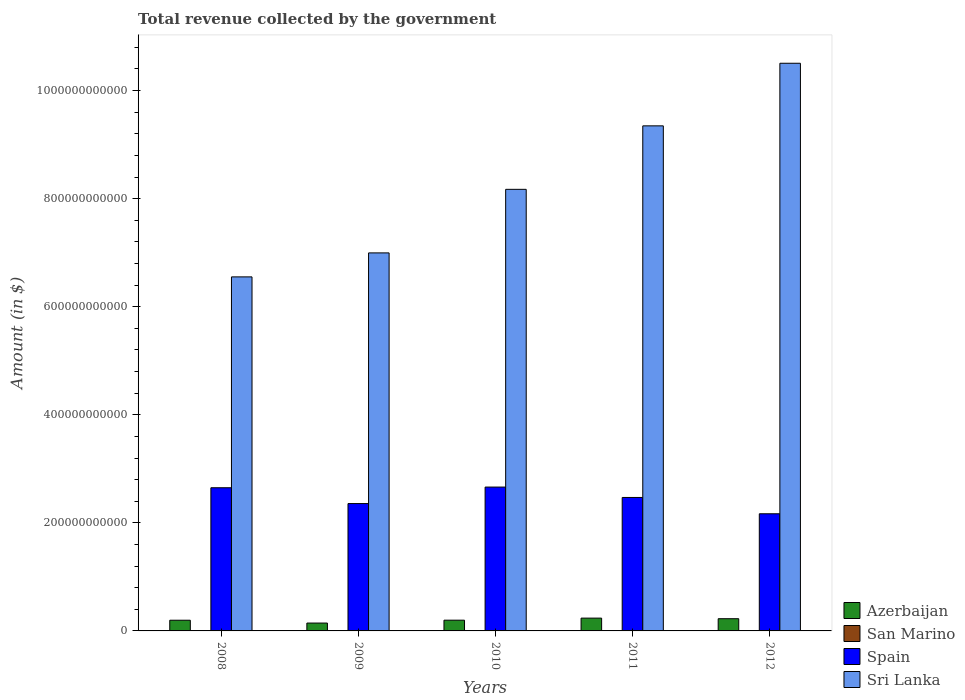How many different coloured bars are there?
Give a very brief answer. 4. Are the number of bars per tick equal to the number of legend labels?
Give a very brief answer. Yes. Are the number of bars on each tick of the X-axis equal?
Provide a short and direct response. Yes. What is the total revenue collected by the government in Azerbaijan in 2009?
Offer a terse response. 1.46e+1. Across all years, what is the maximum total revenue collected by the government in Azerbaijan?
Offer a very short reply. 2.37e+1. Across all years, what is the minimum total revenue collected by the government in Sri Lanka?
Keep it short and to the point. 6.55e+11. What is the total total revenue collected by the government in Sri Lanka in the graph?
Give a very brief answer. 4.16e+12. What is the difference between the total revenue collected by the government in Spain in 2011 and that in 2012?
Offer a terse response. 3.02e+1. What is the difference between the total revenue collected by the government in Sri Lanka in 2010 and the total revenue collected by the government in Azerbaijan in 2009?
Your answer should be very brief. 8.03e+11. What is the average total revenue collected by the government in Azerbaijan per year?
Keep it short and to the point. 2.01e+1. In the year 2010, what is the difference between the total revenue collected by the government in Spain and total revenue collected by the government in Azerbaijan?
Ensure brevity in your answer.  2.46e+11. In how many years, is the total revenue collected by the government in Azerbaijan greater than 80000000000 $?
Your response must be concise. 0. What is the ratio of the total revenue collected by the government in Azerbaijan in 2011 to that in 2012?
Your answer should be very brief. 1.05. Is the total revenue collected by the government in Sri Lanka in 2008 less than that in 2009?
Give a very brief answer. Yes. Is the difference between the total revenue collected by the government in Spain in 2010 and 2011 greater than the difference between the total revenue collected by the government in Azerbaijan in 2010 and 2011?
Your response must be concise. Yes. What is the difference between the highest and the second highest total revenue collected by the government in Azerbaijan?
Give a very brief answer. 1.09e+09. What is the difference between the highest and the lowest total revenue collected by the government in Sri Lanka?
Your response must be concise. 3.95e+11. Is it the case that in every year, the sum of the total revenue collected by the government in Spain and total revenue collected by the government in Azerbaijan is greater than the sum of total revenue collected by the government in Sri Lanka and total revenue collected by the government in San Marino?
Offer a very short reply. Yes. What does the 1st bar from the left in 2010 represents?
Offer a very short reply. Azerbaijan. What does the 4th bar from the right in 2009 represents?
Give a very brief answer. Azerbaijan. What is the difference between two consecutive major ticks on the Y-axis?
Offer a terse response. 2.00e+11. Does the graph contain any zero values?
Ensure brevity in your answer.  No. Does the graph contain grids?
Ensure brevity in your answer.  No. Where does the legend appear in the graph?
Give a very brief answer. Bottom right. How many legend labels are there?
Provide a short and direct response. 4. What is the title of the graph?
Provide a succinct answer. Total revenue collected by the government. What is the label or title of the X-axis?
Offer a terse response. Years. What is the label or title of the Y-axis?
Provide a succinct answer. Amount (in $). What is the Amount (in $) in Azerbaijan in 2008?
Your answer should be very brief. 1.98e+1. What is the Amount (in $) of San Marino in 2008?
Ensure brevity in your answer.  5.91e+08. What is the Amount (in $) of Spain in 2008?
Provide a short and direct response. 2.65e+11. What is the Amount (in $) of Sri Lanka in 2008?
Ensure brevity in your answer.  6.55e+11. What is the Amount (in $) of Azerbaijan in 2009?
Offer a terse response. 1.46e+1. What is the Amount (in $) of San Marino in 2009?
Offer a very short reply. 5.62e+08. What is the Amount (in $) in Spain in 2009?
Your answer should be very brief. 2.36e+11. What is the Amount (in $) of Sri Lanka in 2009?
Make the answer very short. 7.00e+11. What is the Amount (in $) of Azerbaijan in 2010?
Your answer should be very brief. 1.99e+1. What is the Amount (in $) in San Marino in 2010?
Your answer should be very brief. 5.31e+08. What is the Amount (in $) in Spain in 2010?
Keep it short and to the point. 2.66e+11. What is the Amount (in $) in Sri Lanka in 2010?
Give a very brief answer. 8.17e+11. What is the Amount (in $) in Azerbaijan in 2011?
Keep it short and to the point. 2.37e+1. What is the Amount (in $) of San Marino in 2011?
Ensure brevity in your answer.  5.23e+08. What is the Amount (in $) in Spain in 2011?
Give a very brief answer. 2.47e+11. What is the Amount (in $) in Sri Lanka in 2011?
Keep it short and to the point. 9.35e+11. What is the Amount (in $) of Azerbaijan in 2012?
Your answer should be very brief. 2.26e+1. What is the Amount (in $) of San Marino in 2012?
Give a very brief answer. 5.53e+08. What is the Amount (in $) of Spain in 2012?
Make the answer very short. 2.17e+11. What is the Amount (in $) in Sri Lanka in 2012?
Keep it short and to the point. 1.05e+12. Across all years, what is the maximum Amount (in $) of Azerbaijan?
Your answer should be compact. 2.37e+1. Across all years, what is the maximum Amount (in $) of San Marino?
Offer a terse response. 5.91e+08. Across all years, what is the maximum Amount (in $) in Spain?
Your answer should be very brief. 2.66e+11. Across all years, what is the maximum Amount (in $) of Sri Lanka?
Provide a succinct answer. 1.05e+12. Across all years, what is the minimum Amount (in $) in Azerbaijan?
Your response must be concise. 1.46e+1. Across all years, what is the minimum Amount (in $) of San Marino?
Your answer should be compact. 5.23e+08. Across all years, what is the minimum Amount (in $) in Spain?
Keep it short and to the point. 2.17e+11. Across all years, what is the minimum Amount (in $) in Sri Lanka?
Offer a very short reply. 6.55e+11. What is the total Amount (in $) in Azerbaijan in the graph?
Ensure brevity in your answer.  1.01e+11. What is the total Amount (in $) in San Marino in the graph?
Keep it short and to the point. 2.76e+09. What is the total Amount (in $) in Spain in the graph?
Provide a short and direct response. 1.23e+12. What is the total Amount (in $) in Sri Lanka in the graph?
Provide a succinct answer. 4.16e+12. What is the difference between the Amount (in $) in Azerbaijan in 2008 and that in 2009?
Your answer should be compact. 5.23e+09. What is the difference between the Amount (in $) in San Marino in 2008 and that in 2009?
Your response must be concise. 2.87e+07. What is the difference between the Amount (in $) of Spain in 2008 and that in 2009?
Keep it short and to the point. 2.93e+1. What is the difference between the Amount (in $) in Sri Lanka in 2008 and that in 2009?
Keep it short and to the point. -4.44e+1. What is the difference between the Amount (in $) in Azerbaijan in 2008 and that in 2010?
Provide a short and direct response. -9.75e+07. What is the difference between the Amount (in $) of San Marino in 2008 and that in 2010?
Provide a short and direct response. 6.02e+07. What is the difference between the Amount (in $) of Spain in 2008 and that in 2010?
Keep it short and to the point. -1.23e+09. What is the difference between the Amount (in $) of Sri Lanka in 2008 and that in 2010?
Ensure brevity in your answer.  -1.62e+11. What is the difference between the Amount (in $) in Azerbaijan in 2008 and that in 2011?
Your answer should be very brief. -3.90e+09. What is the difference between the Amount (in $) of San Marino in 2008 and that in 2011?
Ensure brevity in your answer.  6.76e+07. What is the difference between the Amount (in $) of Spain in 2008 and that in 2011?
Your answer should be compact. 1.80e+1. What is the difference between the Amount (in $) of Sri Lanka in 2008 and that in 2011?
Make the answer very short. -2.80e+11. What is the difference between the Amount (in $) in Azerbaijan in 2008 and that in 2012?
Your response must be concise. -2.81e+09. What is the difference between the Amount (in $) of San Marino in 2008 and that in 2012?
Keep it short and to the point. 3.76e+07. What is the difference between the Amount (in $) in Spain in 2008 and that in 2012?
Provide a short and direct response. 4.82e+1. What is the difference between the Amount (in $) in Sri Lanka in 2008 and that in 2012?
Give a very brief answer. -3.95e+11. What is the difference between the Amount (in $) in Azerbaijan in 2009 and that in 2010?
Your answer should be very brief. -5.33e+09. What is the difference between the Amount (in $) in San Marino in 2009 and that in 2010?
Provide a succinct answer. 3.15e+07. What is the difference between the Amount (in $) in Spain in 2009 and that in 2010?
Make the answer very short. -3.05e+1. What is the difference between the Amount (in $) of Sri Lanka in 2009 and that in 2010?
Make the answer very short. -1.18e+11. What is the difference between the Amount (in $) of Azerbaijan in 2009 and that in 2011?
Your response must be concise. -9.13e+09. What is the difference between the Amount (in $) of San Marino in 2009 and that in 2011?
Ensure brevity in your answer.  3.89e+07. What is the difference between the Amount (in $) of Spain in 2009 and that in 2011?
Offer a very short reply. -1.13e+1. What is the difference between the Amount (in $) in Sri Lanka in 2009 and that in 2011?
Offer a terse response. -2.35e+11. What is the difference between the Amount (in $) in Azerbaijan in 2009 and that in 2012?
Your answer should be compact. -8.04e+09. What is the difference between the Amount (in $) in San Marino in 2009 and that in 2012?
Provide a succinct answer. 8.90e+06. What is the difference between the Amount (in $) in Spain in 2009 and that in 2012?
Offer a very short reply. 1.89e+1. What is the difference between the Amount (in $) of Sri Lanka in 2009 and that in 2012?
Provide a succinct answer. -3.51e+11. What is the difference between the Amount (in $) of Azerbaijan in 2010 and that in 2011?
Provide a short and direct response. -3.80e+09. What is the difference between the Amount (in $) in San Marino in 2010 and that in 2011?
Give a very brief answer. 7.36e+06. What is the difference between the Amount (in $) of Spain in 2010 and that in 2011?
Keep it short and to the point. 1.92e+1. What is the difference between the Amount (in $) in Sri Lanka in 2010 and that in 2011?
Your answer should be compact. -1.17e+11. What is the difference between the Amount (in $) in Azerbaijan in 2010 and that in 2012?
Your answer should be compact. -2.71e+09. What is the difference between the Amount (in $) in San Marino in 2010 and that in 2012?
Keep it short and to the point. -2.26e+07. What is the difference between the Amount (in $) in Spain in 2010 and that in 2012?
Your answer should be compact. 4.94e+1. What is the difference between the Amount (in $) of Sri Lanka in 2010 and that in 2012?
Ensure brevity in your answer.  -2.33e+11. What is the difference between the Amount (in $) of Azerbaijan in 2011 and that in 2012?
Offer a very short reply. 1.09e+09. What is the difference between the Amount (in $) of San Marino in 2011 and that in 2012?
Keep it short and to the point. -3.00e+07. What is the difference between the Amount (in $) of Spain in 2011 and that in 2012?
Keep it short and to the point. 3.02e+1. What is the difference between the Amount (in $) in Sri Lanka in 2011 and that in 2012?
Provide a succinct answer. -1.16e+11. What is the difference between the Amount (in $) of Azerbaijan in 2008 and the Amount (in $) of San Marino in 2009?
Make the answer very short. 1.92e+1. What is the difference between the Amount (in $) in Azerbaijan in 2008 and the Amount (in $) in Spain in 2009?
Your answer should be compact. -2.16e+11. What is the difference between the Amount (in $) of Azerbaijan in 2008 and the Amount (in $) of Sri Lanka in 2009?
Offer a terse response. -6.80e+11. What is the difference between the Amount (in $) of San Marino in 2008 and the Amount (in $) of Spain in 2009?
Make the answer very short. -2.35e+11. What is the difference between the Amount (in $) of San Marino in 2008 and the Amount (in $) of Sri Lanka in 2009?
Ensure brevity in your answer.  -6.99e+11. What is the difference between the Amount (in $) of Spain in 2008 and the Amount (in $) of Sri Lanka in 2009?
Offer a very short reply. -4.35e+11. What is the difference between the Amount (in $) of Azerbaijan in 2008 and the Amount (in $) of San Marino in 2010?
Offer a very short reply. 1.93e+1. What is the difference between the Amount (in $) in Azerbaijan in 2008 and the Amount (in $) in Spain in 2010?
Your answer should be very brief. -2.46e+11. What is the difference between the Amount (in $) in Azerbaijan in 2008 and the Amount (in $) in Sri Lanka in 2010?
Your response must be concise. -7.97e+11. What is the difference between the Amount (in $) of San Marino in 2008 and the Amount (in $) of Spain in 2010?
Keep it short and to the point. -2.66e+11. What is the difference between the Amount (in $) of San Marino in 2008 and the Amount (in $) of Sri Lanka in 2010?
Offer a terse response. -8.17e+11. What is the difference between the Amount (in $) of Spain in 2008 and the Amount (in $) of Sri Lanka in 2010?
Give a very brief answer. -5.52e+11. What is the difference between the Amount (in $) in Azerbaijan in 2008 and the Amount (in $) in San Marino in 2011?
Keep it short and to the point. 1.93e+1. What is the difference between the Amount (in $) in Azerbaijan in 2008 and the Amount (in $) in Spain in 2011?
Offer a terse response. -2.27e+11. What is the difference between the Amount (in $) of Azerbaijan in 2008 and the Amount (in $) of Sri Lanka in 2011?
Provide a short and direct response. -9.15e+11. What is the difference between the Amount (in $) in San Marino in 2008 and the Amount (in $) in Spain in 2011?
Keep it short and to the point. -2.46e+11. What is the difference between the Amount (in $) in San Marino in 2008 and the Amount (in $) in Sri Lanka in 2011?
Your answer should be compact. -9.34e+11. What is the difference between the Amount (in $) of Spain in 2008 and the Amount (in $) of Sri Lanka in 2011?
Your response must be concise. -6.70e+11. What is the difference between the Amount (in $) in Azerbaijan in 2008 and the Amount (in $) in San Marino in 2012?
Offer a very short reply. 1.92e+1. What is the difference between the Amount (in $) of Azerbaijan in 2008 and the Amount (in $) of Spain in 2012?
Provide a short and direct response. -1.97e+11. What is the difference between the Amount (in $) of Azerbaijan in 2008 and the Amount (in $) of Sri Lanka in 2012?
Your response must be concise. -1.03e+12. What is the difference between the Amount (in $) in San Marino in 2008 and the Amount (in $) in Spain in 2012?
Give a very brief answer. -2.16e+11. What is the difference between the Amount (in $) of San Marino in 2008 and the Amount (in $) of Sri Lanka in 2012?
Provide a succinct answer. -1.05e+12. What is the difference between the Amount (in $) of Spain in 2008 and the Amount (in $) of Sri Lanka in 2012?
Your answer should be very brief. -7.86e+11. What is the difference between the Amount (in $) of Azerbaijan in 2009 and the Amount (in $) of San Marino in 2010?
Keep it short and to the point. 1.40e+1. What is the difference between the Amount (in $) in Azerbaijan in 2009 and the Amount (in $) in Spain in 2010?
Give a very brief answer. -2.52e+11. What is the difference between the Amount (in $) in Azerbaijan in 2009 and the Amount (in $) in Sri Lanka in 2010?
Offer a very short reply. -8.03e+11. What is the difference between the Amount (in $) of San Marino in 2009 and the Amount (in $) of Spain in 2010?
Offer a very short reply. -2.66e+11. What is the difference between the Amount (in $) of San Marino in 2009 and the Amount (in $) of Sri Lanka in 2010?
Make the answer very short. -8.17e+11. What is the difference between the Amount (in $) in Spain in 2009 and the Amount (in $) in Sri Lanka in 2010?
Offer a terse response. -5.82e+11. What is the difference between the Amount (in $) of Azerbaijan in 2009 and the Amount (in $) of San Marino in 2011?
Offer a terse response. 1.40e+1. What is the difference between the Amount (in $) in Azerbaijan in 2009 and the Amount (in $) in Spain in 2011?
Make the answer very short. -2.32e+11. What is the difference between the Amount (in $) of Azerbaijan in 2009 and the Amount (in $) of Sri Lanka in 2011?
Your answer should be compact. -9.20e+11. What is the difference between the Amount (in $) in San Marino in 2009 and the Amount (in $) in Spain in 2011?
Your answer should be very brief. -2.46e+11. What is the difference between the Amount (in $) of San Marino in 2009 and the Amount (in $) of Sri Lanka in 2011?
Your response must be concise. -9.34e+11. What is the difference between the Amount (in $) of Spain in 2009 and the Amount (in $) of Sri Lanka in 2011?
Provide a succinct answer. -6.99e+11. What is the difference between the Amount (in $) of Azerbaijan in 2009 and the Amount (in $) of San Marino in 2012?
Offer a terse response. 1.40e+1. What is the difference between the Amount (in $) in Azerbaijan in 2009 and the Amount (in $) in Spain in 2012?
Give a very brief answer. -2.02e+11. What is the difference between the Amount (in $) in Azerbaijan in 2009 and the Amount (in $) in Sri Lanka in 2012?
Offer a very short reply. -1.04e+12. What is the difference between the Amount (in $) of San Marino in 2009 and the Amount (in $) of Spain in 2012?
Make the answer very short. -2.16e+11. What is the difference between the Amount (in $) in San Marino in 2009 and the Amount (in $) in Sri Lanka in 2012?
Offer a terse response. -1.05e+12. What is the difference between the Amount (in $) of Spain in 2009 and the Amount (in $) of Sri Lanka in 2012?
Your answer should be very brief. -8.15e+11. What is the difference between the Amount (in $) in Azerbaijan in 2010 and the Amount (in $) in San Marino in 2011?
Keep it short and to the point. 1.94e+1. What is the difference between the Amount (in $) in Azerbaijan in 2010 and the Amount (in $) in Spain in 2011?
Offer a very short reply. -2.27e+11. What is the difference between the Amount (in $) in Azerbaijan in 2010 and the Amount (in $) in Sri Lanka in 2011?
Your response must be concise. -9.15e+11. What is the difference between the Amount (in $) in San Marino in 2010 and the Amount (in $) in Spain in 2011?
Provide a succinct answer. -2.46e+11. What is the difference between the Amount (in $) of San Marino in 2010 and the Amount (in $) of Sri Lanka in 2011?
Make the answer very short. -9.34e+11. What is the difference between the Amount (in $) in Spain in 2010 and the Amount (in $) in Sri Lanka in 2011?
Keep it short and to the point. -6.69e+11. What is the difference between the Amount (in $) of Azerbaijan in 2010 and the Amount (in $) of San Marino in 2012?
Provide a succinct answer. 1.93e+1. What is the difference between the Amount (in $) of Azerbaijan in 2010 and the Amount (in $) of Spain in 2012?
Offer a very short reply. -1.97e+11. What is the difference between the Amount (in $) in Azerbaijan in 2010 and the Amount (in $) in Sri Lanka in 2012?
Ensure brevity in your answer.  -1.03e+12. What is the difference between the Amount (in $) in San Marino in 2010 and the Amount (in $) in Spain in 2012?
Provide a short and direct response. -2.16e+11. What is the difference between the Amount (in $) of San Marino in 2010 and the Amount (in $) of Sri Lanka in 2012?
Your answer should be very brief. -1.05e+12. What is the difference between the Amount (in $) in Spain in 2010 and the Amount (in $) in Sri Lanka in 2012?
Your response must be concise. -7.84e+11. What is the difference between the Amount (in $) in Azerbaijan in 2011 and the Amount (in $) in San Marino in 2012?
Offer a terse response. 2.31e+1. What is the difference between the Amount (in $) of Azerbaijan in 2011 and the Amount (in $) of Spain in 2012?
Keep it short and to the point. -1.93e+11. What is the difference between the Amount (in $) in Azerbaijan in 2011 and the Amount (in $) in Sri Lanka in 2012?
Your answer should be very brief. -1.03e+12. What is the difference between the Amount (in $) of San Marino in 2011 and the Amount (in $) of Spain in 2012?
Give a very brief answer. -2.16e+11. What is the difference between the Amount (in $) of San Marino in 2011 and the Amount (in $) of Sri Lanka in 2012?
Ensure brevity in your answer.  -1.05e+12. What is the difference between the Amount (in $) of Spain in 2011 and the Amount (in $) of Sri Lanka in 2012?
Make the answer very short. -8.04e+11. What is the average Amount (in $) in Azerbaijan per year?
Keep it short and to the point. 2.01e+1. What is the average Amount (in $) in San Marino per year?
Give a very brief answer. 5.52e+08. What is the average Amount (in $) in Spain per year?
Your answer should be very brief. 2.46e+11. What is the average Amount (in $) of Sri Lanka per year?
Your response must be concise. 8.32e+11. In the year 2008, what is the difference between the Amount (in $) of Azerbaijan and Amount (in $) of San Marino?
Your answer should be compact. 1.92e+1. In the year 2008, what is the difference between the Amount (in $) in Azerbaijan and Amount (in $) in Spain?
Your answer should be very brief. -2.45e+11. In the year 2008, what is the difference between the Amount (in $) in Azerbaijan and Amount (in $) in Sri Lanka?
Give a very brief answer. -6.35e+11. In the year 2008, what is the difference between the Amount (in $) of San Marino and Amount (in $) of Spain?
Keep it short and to the point. -2.64e+11. In the year 2008, what is the difference between the Amount (in $) of San Marino and Amount (in $) of Sri Lanka?
Provide a short and direct response. -6.55e+11. In the year 2008, what is the difference between the Amount (in $) in Spain and Amount (in $) in Sri Lanka?
Offer a very short reply. -3.90e+11. In the year 2009, what is the difference between the Amount (in $) in Azerbaijan and Amount (in $) in San Marino?
Ensure brevity in your answer.  1.40e+1. In the year 2009, what is the difference between the Amount (in $) in Azerbaijan and Amount (in $) in Spain?
Your response must be concise. -2.21e+11. In the year 2009, what is the difference between the Amount (in $) in Azerbaijan and Amount (in $) in Sri Lanka?
Provide a short and direct response. -6.85e+11. In the year 2009, what is the difference between the Amount (in $) in San Marino and Amount (in $) in Spain?
Keep it short and to the point. -2.35e+11. In the year 2009, what is the difference between the Amount (in $) of San Marino and Amount (in $) of Sri Lanka?
Make the answer very short. -6.99e+11. In the year 2009, what is the difference between the Amount (in $) in Spain and Amount (in $) in Sri Lanka?
Give a very brief answer. -4.64e+11. In the year 2010, what is the difference between the Amount (in $) in Azerbaijan and Amount (in $) in San Marino?
Provide a succinct answer. 1.94e+1. In the year 2010, what is the difference between the Amount (in $) in Azerbaijan and Amount (in $) in Spain?
Offer a terse response. -2.46e+11. In the year 2010, what is the difference between the Amount (in $) of Azerbaijan and Amount (in $) of Sri Lanka?
Provide a succinct answer. -7.97e+11. In the year 2010, what is the difference between the Amount (in $) in San Marino and Amount (in $) in Spain?
Your answer should be compact. -2.66e+11. In the year 2010, what is the difference between the Amount (in $) of San Marino and Amount (in $) of Sri Lanka?
Your response must be concise. -8.17e+11. In the year 2010, what is the difference between the Amount (in $) of Spain and Amount (in $) of Sri Lanka?
Your response must be concise. -5.51e+11. In the year 2011, what is the difference between the Amount (in $) in Azerbaijan and Amount (in $) in San Marino?
Provide a succinct answer. 2.32e+1. In the year 2011, what is the difference between the Amount (in $) in Azerbaijan and Amount (in $) in Spain?
Provide a short and direct response. -2.23e+11. In the year 2011, what is the difference between the Amount (in $) in Azerbaijan and Amount (in $) in Sri Lanka?
Your answer should be very brief. -9.11e+11. In the year 2011, what is the difference between the Amount (in $) in San Marino and Amount (in $) in Spain?
Provide a succinct answer. -2.46e+11. In the year 2011, what is the difference between the Amount (in $) of San Marino and Amount (in $) of Sri Lanka?
Keep it short and to the point. -9.34e+11. In the year 2011, what is the difference between the Amount (in $) in Spain and Amount (in $) in Sri Lanka?
Make the answer very short. -6.88e+11. In the year 2012, what is the difference between the Amount (in $) in Azerbaijan and Amount (in $) in San Marino?
Your answer should be compact. 2.20e+1. In the year 2012, what is the difference between the Amount (in $) in Azerbaijan and Amount (in $) in Spain?
Make the answer very short. -1.94e+11. In the year 2012, what is the difference between the Amount (in $) in Azerbaijan and Amount (in $) in Sri Lanka?
Offer a very short reply. -1.03e+12. In the year 2012, what is the difference between the Amount (in $) in San Marino and Amount (in $) in Spain?
Make the answer very short. -2.16e+11. In the year 2012, what is the difference between the Amount (in $) in San Marino and Amount (in $) in Sri Lanka?
Provide a short and direct response. -1.05e+12. In the year 2012, what is the difference between the Amount (in $) of Spain and Amount (in $) of Sri Lanka?
Offer a terse response. -8.34e+11. What is the ratio of the Amount (in $) of Azerbaijan in 2008 to that in 2009?
Provide a succinct answer. 1.36. What is the ratio of the Amount (in $) in San Marino in 2008 to that in 2009?
Offer a terse response. 1.05. What is the ratio of the Amount (in $) in Spain in 2008 to that in 2009?
Keep it short and to the point. 1.12. What is the ratio of the Amount (in $) in Sri Lanka in 2008 to that in 2009?
Offer a very short reply. 0.94. What is the ratio of the Amount (in $) of San Marino in 2008 to that in 2010?
Your answer should be very brief. 1.11. What is the ratio of the Amount (in $) of Spain in 2008 to that in 2010?
Your response must be concise. 1. What is the ratio of the Amount (in $) of Sri Lanka in 2008 to that in 2010?
Keep it short and to the point. 0.8. What is the ratio of the Amount (in $) in Azerbaijan in 2008 to that in 2011?
Offer a terse response. 0.84. What is the ratio of the Amount (in $) of San Marino in 2008 to that in 2011?
Your answer should be compact. 1.13. What is the ratio of the Amount (in $) of Spain in 2008 to that in 2011?
Ensure brevity in your answer.  1.07. What is the ratio of the Amount (in $) of Sri Lanka in 2008 to that in 2011?
Make the answer very short. 0.7. What is the ratio of the Amount (in $) of Azerbaijan in 2008 to that in 2012?
Give a very brief answer. 0.88. What is the ratio of the Amount (in $) in San Marino in 2008 to that in 2012?
Make the answer very short. 1.07. What is the ratio of the Amount (in $) of Spain in 2008 to that in 2012?
Keep it short and to the point. 1.22. What is the ratio of the Amount (in $) of Sri Lanka in 2008 to that in 2012?
Give a very brief answer. 0.62. What is the ratio of the Amount (in $) in Azerbaijan in 2009 to that in 2010?
Your answer should be compact. 0.73. What is the ratio of the Amount (in $) of San Marino in 2009 to that in 2010?
Ensure brevity in your answer.  1.06. What is the ratio of the Amount (in $) in Spain in 2009 to that in 2010?
Keep it short and to the point. 0.89. What is the ratio of the Amount (in $) of Sri Lanka in 2009 to that in 2010?
Your answer should be compact. 0.86. What is the ratio of the Amount (in $) in Azerbaijan in 2009 to that in 2011?
Provide a short and direct response. 0.61. What is the ratio of the Amount (in $) of San Marino in 2009 to that in 2011?
Make the answer very short. 1.07. What is the ratio of the Amount (in $) in Spain in 2009 to that in 2011?
Your response must be concise. 0.95. What is the ratio of the Amount (in $) of Sri Lanka in 2009 to that in 2011?
Your response must be concise. 0.75. What is the ratio of the Amount (in $) of Azerbaijan in 2009 to that in 2012?
Keep it short and to the point. 0.64. What is the ratio of the Amount (in $) in San Marino in 2009 to that in 2012?
Offer a very short reply. 1.02. What is the ratio of the Amount (in $) in Spain in 2009 to that in 2012?
Give a very brief answer. 1.09. What is the ratio of the Amount (in $) in Sri Lanka in 2009 to that in 2012?
Your answer should be compact. 0.67. What is the ratio of the Amount (in $) of Azerbaijan in 2010 to that in 2011?
Give a very brief answer. 0.84. What is the ratio of the Amount (in $) in San Marino in 2010 to that in 2011?
Your answer should be compact. 1.01. What is the ratio of the Amount (in $) in Spain in 2010 to that in 2011?
Give a very brief answer. 1.08. What is the ratio of the Amount (in $) in Sri Lanka in 2010 to that in 2011?
Your answer should be compact. 0.87. What is the ratio of the Amount (in $) of Azerbaijan in 2010 to that in 2012?
Offer a very short reply. 0.88. What is the ratio of the Amount (in $) of San Marino in 2010 to that in 2012?
Keep it short and to the point. 0.96. What is the ratio of the Amount (in $) of Spain in 2010 to that in 2012?
Offer a terse response. 1.23. What is the ratio of the Amount (in $) in Sri Lanka in 2010 to that in 2012?
Your response must be concise. 0.78. What is the ratio of the Amount (in $) of Azerbaijan in 2011 to that in 2012?
Your answer should be very brief. 1.05. What is the ratio of the Amount (in $) in San Marino in 2011 to that in 2012?
Offer a very short reply. 0.95. What is the ratio of the Amount (in $) of Spain in 2011 to that in 2012?
Your answer should be very brief. 1.14. What is the ratio of the Amount (in $) in Sri Lanka in 2011 to that in 2012?
Your answer should be very brief. 0.89. What is the difference between the highest and the second highest Amount (in $) of Azerbaijan?
Your answer should be very brief. 1.09e+09. What is the difference between the highest and the second highest Amount (in $) in San Marino?
Offer a terse response. 2.87e+07. What is the difference between the highest and the second highest Amount (in $) in Spain?
Offer a very short reply. 1.23e+09. What is the difference between the highest and the second highest Amount (in $) in Sri Lanka?
Your response must be concise. 1.16e+11. What is the difference between the highest and the lowest Amount (in $) in Azerbaijan?
Provide a succinct answer. 9.13e+09. What is the difference between the highest and the lowest Amount (in $) of San Marino?
Offer a very short reply. 6.76e+07. What is the difference between the highest and the lowest Amount (in $) of Spain?
Provide a succinct answer. 4.94e+1. What is the difference between the highest and the lowest Amount (in $) of Sri Lanka?
Provide a short and direct response. 3.95e+11. 